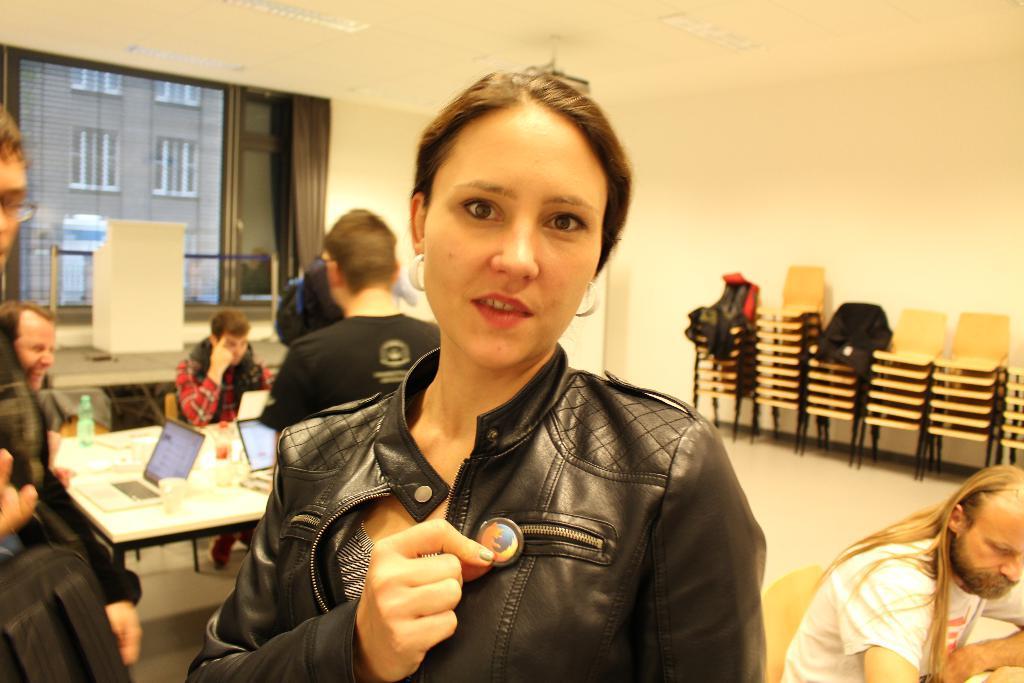Could you give a brief overview of what you see in this image? In this image I can see a woman standing. At the background there are few people sitting on the chair. On the table there is a laptop,bottle. There are chairs. At the back side I can see a building. 